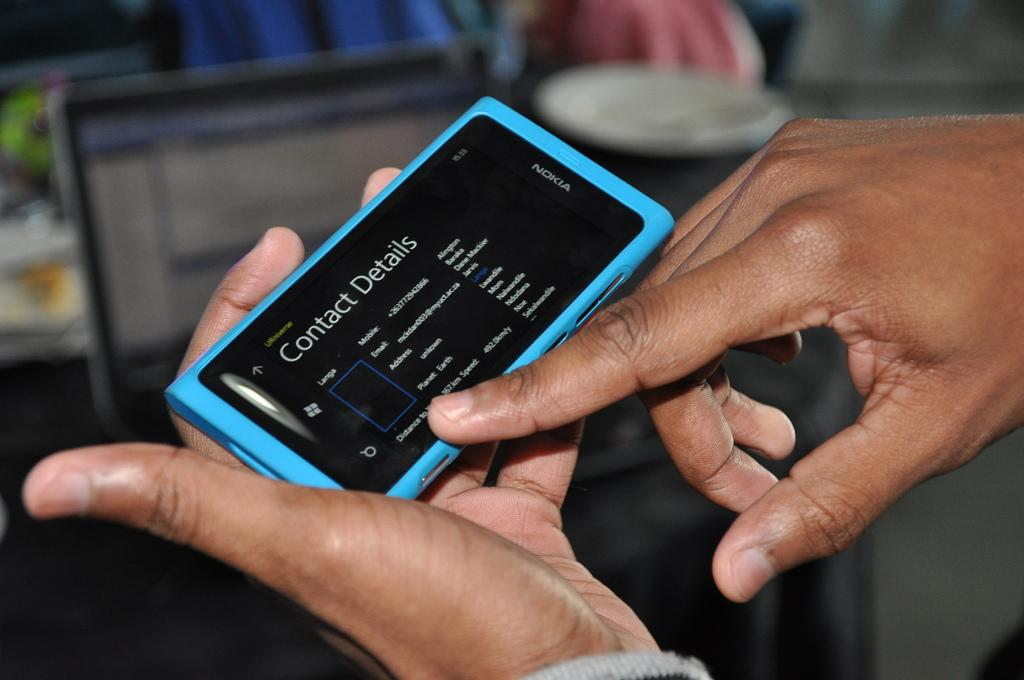<image>
Provide a brief description of the given image. Nokia phone with the contact details screen open. 